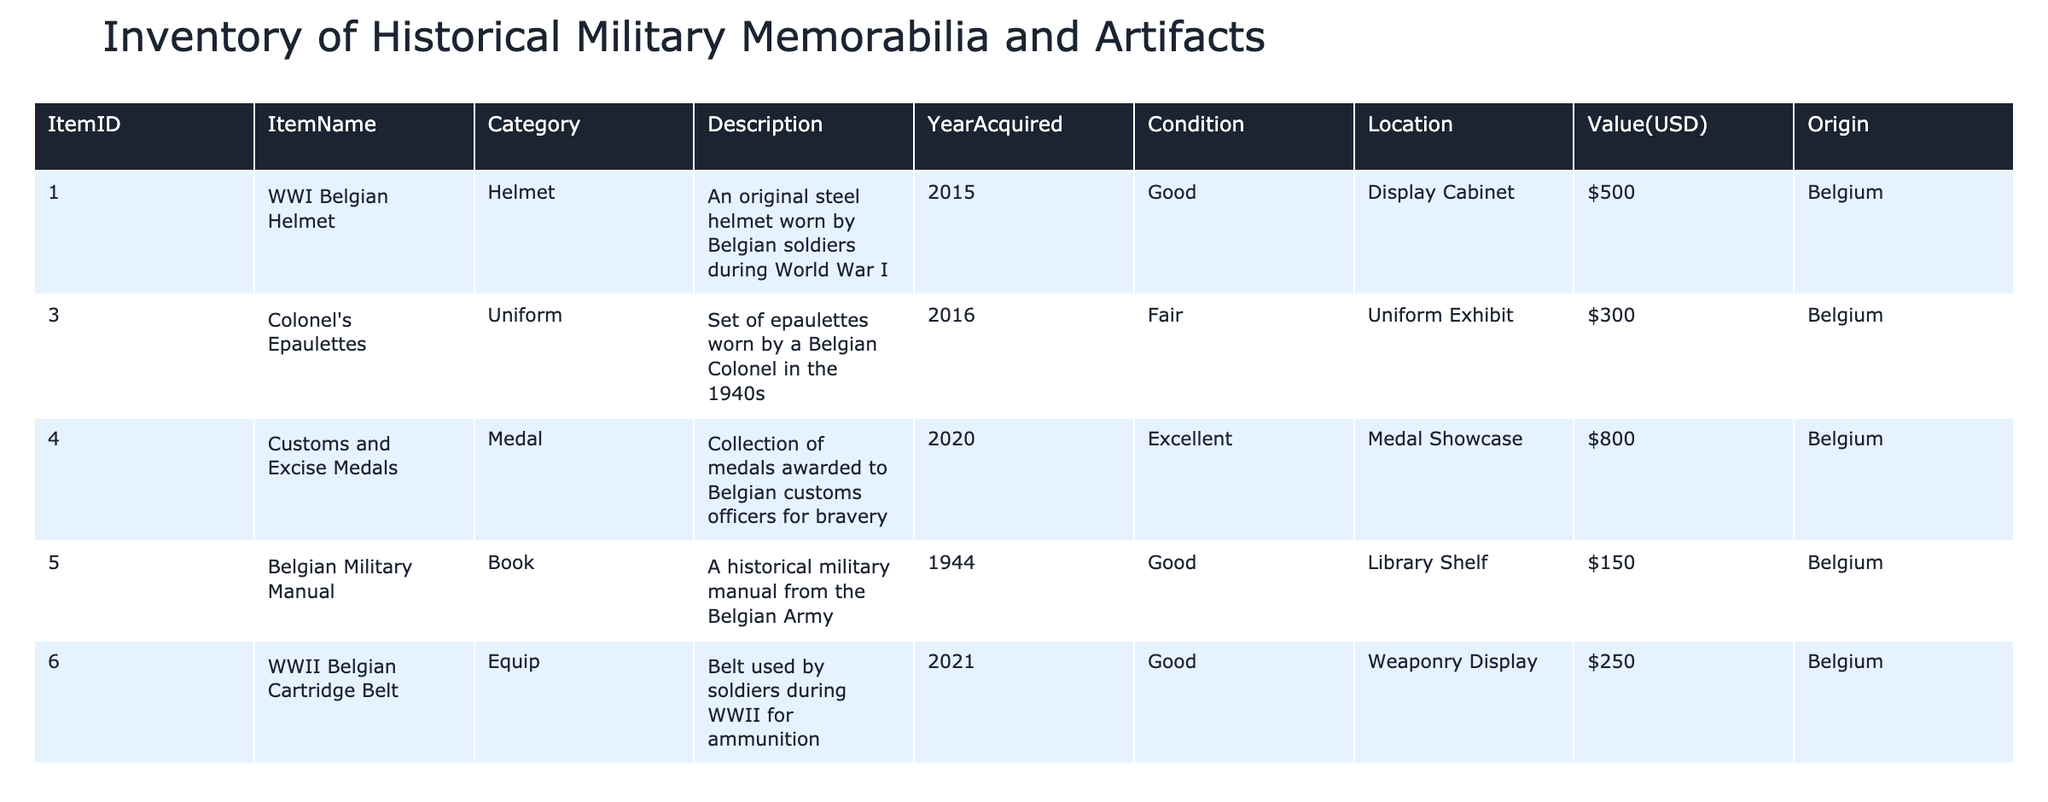What is the total value of all the items in the inventory? To find the total value, we must sum the values of all items. The values are $500 (Helmet) + $300 (Epaulettes) + $800 (Medals) + $150 (Manual) + $250 (Belt) + $600 (Plaque) + $400 (Posters) + $350 (Watch) = $3,350.
Answer: $3,350 Which item has the highest value? The item with the highest value is the Customs and Excise Medals, valued at $800.
Answer: Customs and Excise Medals Are there any items acquired in the year 2020? Yes, there are two items acquired in 2020: the Customs and Excise Medals and the Military Watch.
Answer: Yes What is the average value of items in fair condition? The only item in fair condition is the Colonel's Epaulettes, valued at $300. Since there is just one item, the average value is $300/1 = $300.
Answer: $300 Is there a memorial plaque in the inventory? Yes, there is a Fallen Soldier Plaque which honors soldiers from Belgium who lost their lives in combat.
Answer: Yes How many items are from the WWII era or later? Looking at the acquisition years, the items from WWII or later are: WWI Belgian Helmet (2015), Colonel's Epaulettes (2016), Customs and Excise Medals (2020), WWII Belgian Cartridge Belt (2021), Fallen Soldier Plaque (2019), Posters of the Battle of Yser (2017), and Military Watch (2020). That totals to 7 items.
Answer: 7 Which item was acquired the earliest, and what is its value? The earliest acquired item is the Belgian Military Manual, which was acquired in 1944. Its value is $150.
Answer: Belgian Military Manual, $150 What percentage of the total inventory value does the Belgian Military Manual represent? To determine the percentage, divide the value of the manual ($150) by the total value of the inventory ($3,350), then multiply by 100. (150/3350) * 100 = 4.48%. Therefore, the Belgian Military Manual represents approximately 4.48% of the total inventory value.
Answer: 4.48% 